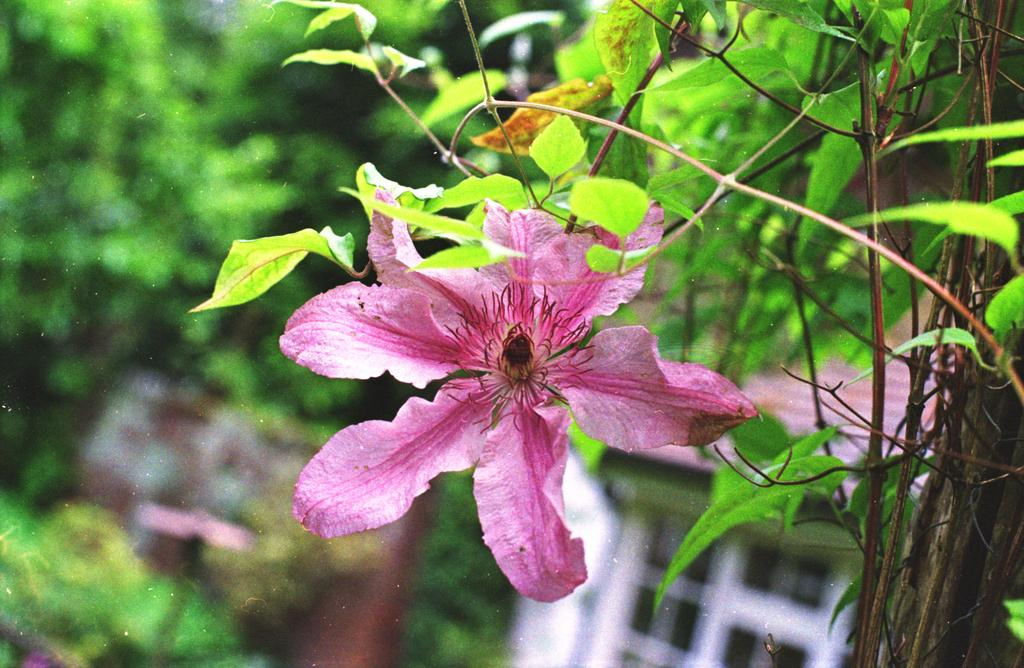What type of plant is in the image? The image contains a plant with a flower and leaves. Can you describe the plant's flower? The plant has a flower, but the specific details cannot be determined from the image. What else can be seen in the image besides the plant? A window is visible in the bottom right corner of the image. How would you describe the background of the image? The background of the image is blurry. What news story is being discussed by the plant in the image? There is no indication in the image that the plant is discussing any news stories, as plants do not have the ability to communicate or understand human language. 